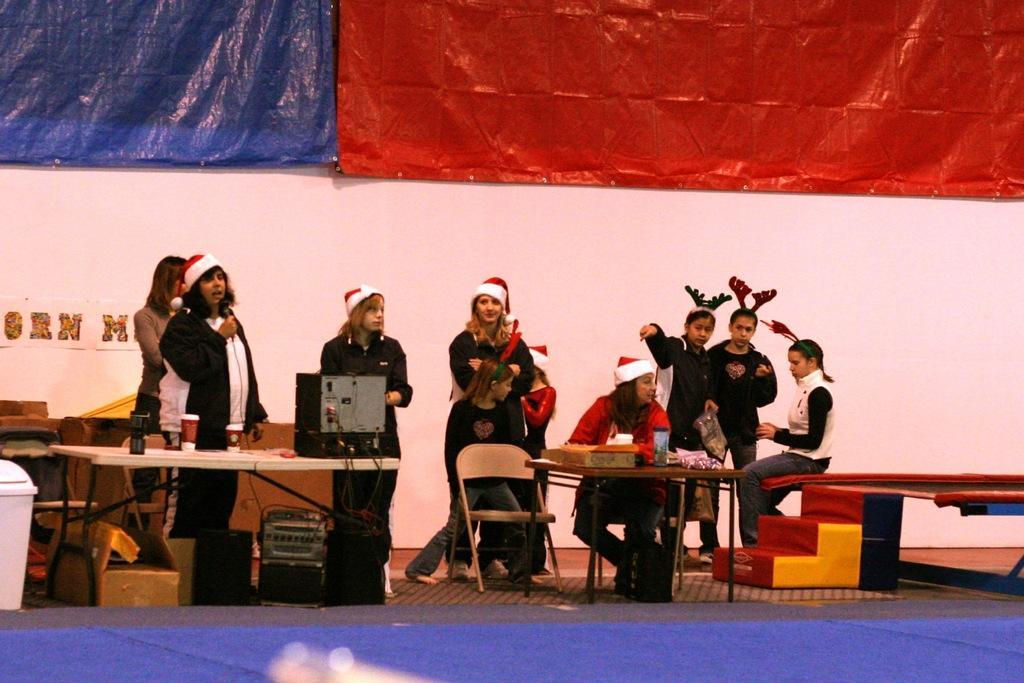Could you give a brief overview of what you see in this image? We can see red and blue cover sheets over a wall. Here we can see few persons standing near the table and few are sitting on chairs. On the table we can see devices, glasses, bottles. These are stairs and it is a platform. under the table we can see device and a cardboard box. 